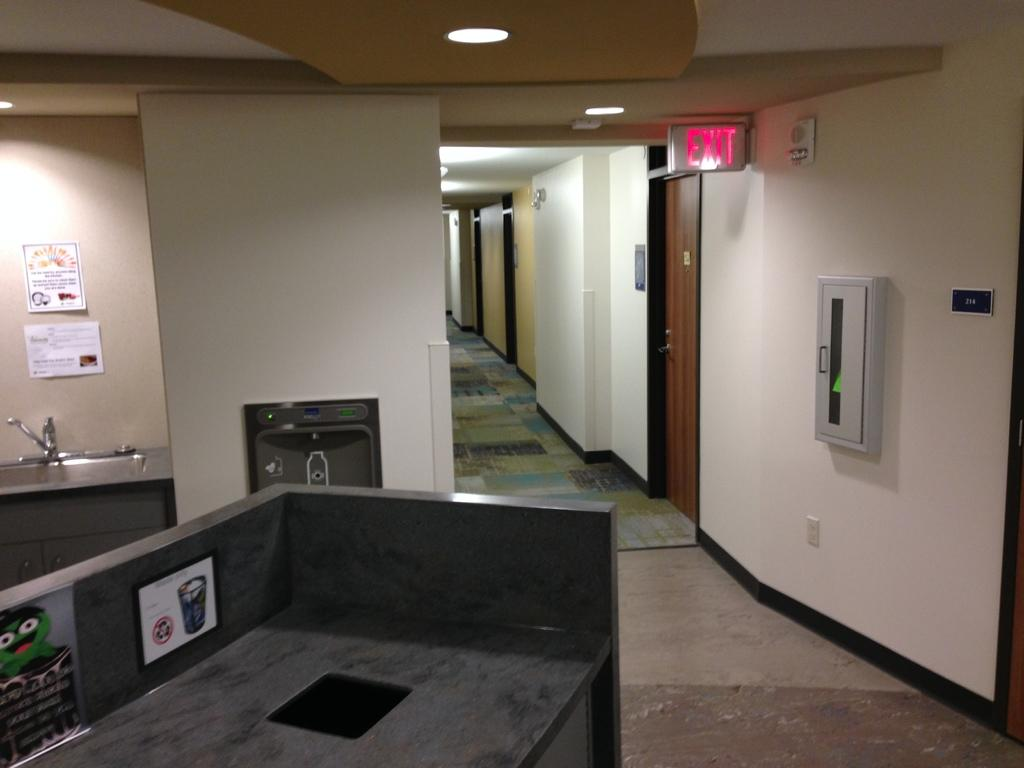Provide a one-sentence caption for the provided image. Building that contains room, a sink, counter, and exit sign. 